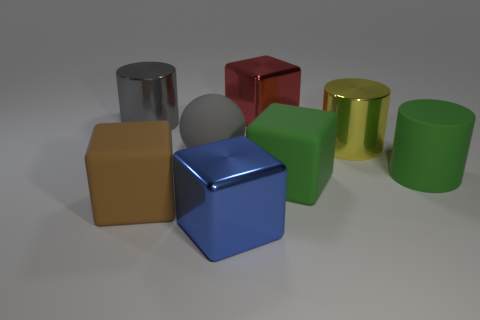Which object stands out the most and why? The blue cube stands out the most due to its vibrant color and position at the center of the image. Its reflective surface also catches the light, making it particularly eye-catching. 